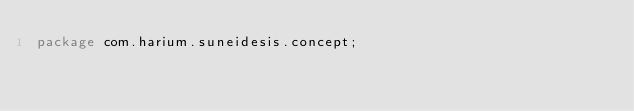<code> <loc_0><loc_0><loc_500><loc_500><_Java_>package com.harium.suneidesis.concept;
</code> 